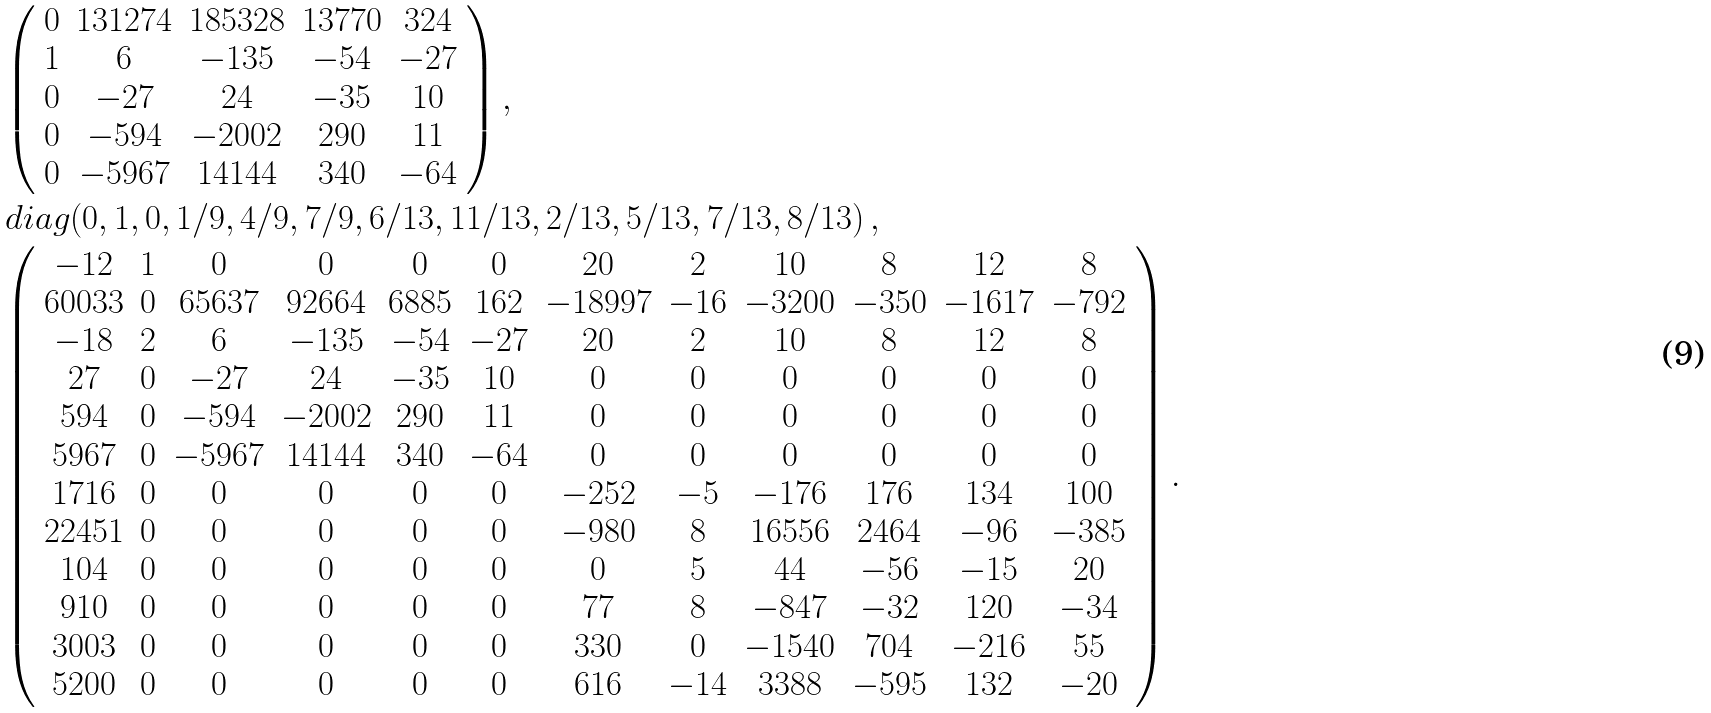Convert formula to latex. <formula><loc_0><loc_0><loc_500><loc_500>& { \left ( \begin{array} { c c c c c } 0 & 1 3 1 2 7 4 & 1 8 5 3 2 8 & 1 3 7 7 0 & 3 2 4 \\ 1 & 6 & - 1 3 5 & - 5 4 & - 2 7 \\ 0 & - 2 7 & 2 4 & - 3 5 & 1 0 \\ 0 & - 5 9 4 & - 2 0 0 2 & 2 9 0 & 1 1 \\ 0 & - 5 9 6 7 & 1 4 1 4 4 & 3 4 0 & - 6 4 \end{array} \right ) } \, , \\ & d i a g ( 0 , 1 , 0 , 1 / 9 , 4 / 9 , 7 / 9 , 6 / 1 3 , 1 1 / 1 3 , 2 / 1 3 , 5 / 1 3 , 7 / 1 3 , 8 / 1 3 ) \, , \\ & { \left ( \begin{array} { c c c c c c c c c c c c } - 1 2 & 1 & 0 & 0 & 0 & 0 & 2 0 & 2 & 1 0 & 8 & 1 2 & 8 \\ 6 0 0 3 3 & 0 & 6 5 6 3 7 & 9 2 6 6 4 & 6 8 8 5 & 1 6 2 & - 1 8 9 9 7 & - 1 6 & - 3 2 0 0 & - 3 5 0 & - 1 6 1 7 & - 7 9 2 \\ - 1 8 & 2 & 6 & - 1 3 5 & - 5 4 & - 2 7 & 2 0 & 2 & 1 0 & 8 & 1 2 & 8 \\ 2 7 & 0 & - 2 7 & 2 4 & - 3 5 & 1 0 & 0 & 0 & 0 & 0 & 0 & 0 \\ 5 9 4 & 0 & - 5 9 4 & - 2 0 0 2 & 2 9 0 & 1 1 & 0 & 0 & 0 & 0 & 0 & 0 \\ 5 9 6 7 & 0 & - 5 9 6 7 & 1 4 1 4 4 & 3 4 0 & - 6 4 & 0 & 0 & 0 & 0 & 0 & 0 \\ 1 7 1 6 & 0 & 0 & 0 & 0 & 0 & - 2 5 2 & - 5 & - 1 7 6 & 1 7 6 & 1 3 4 & 1 0 0 \\ 2 2 4 5 1 & 0 & 0 & 0 & 0 & 0 & - 9 8 0 & 8 & 1 6 5 5 6 & 2 4 6 4 & - 9 6 & - 3 8 5 \\ 1 0 4 & 0 & 0 & 0 & 0 & 0 & 0 & 5 & 4 4 & - 5 6 & - 1 5 & 2 0 \\ 9 1 0 & 0 & 0 & 0 & 0 & 0 & 7 7 & 8 & - 8 4 7 & - 3 2 & 1 2 0 & - 3 4 \\ 3 0 0 3 & 0 & 0 & 0 & 0 & 0 & 3 3 0 & 0 & - 1 5 4 0 & 7 0 4 & - 2 1 6 & 5 5 \\ 5 2 0 0 & 0 & 0 & 0 & 0 & 0 & 6 1 6 & - 1 4 & 3 3 8 8 & - 5 9 5 & 1 3 2 & - 2 0 \end{array} \right ) } \, .</formula> 